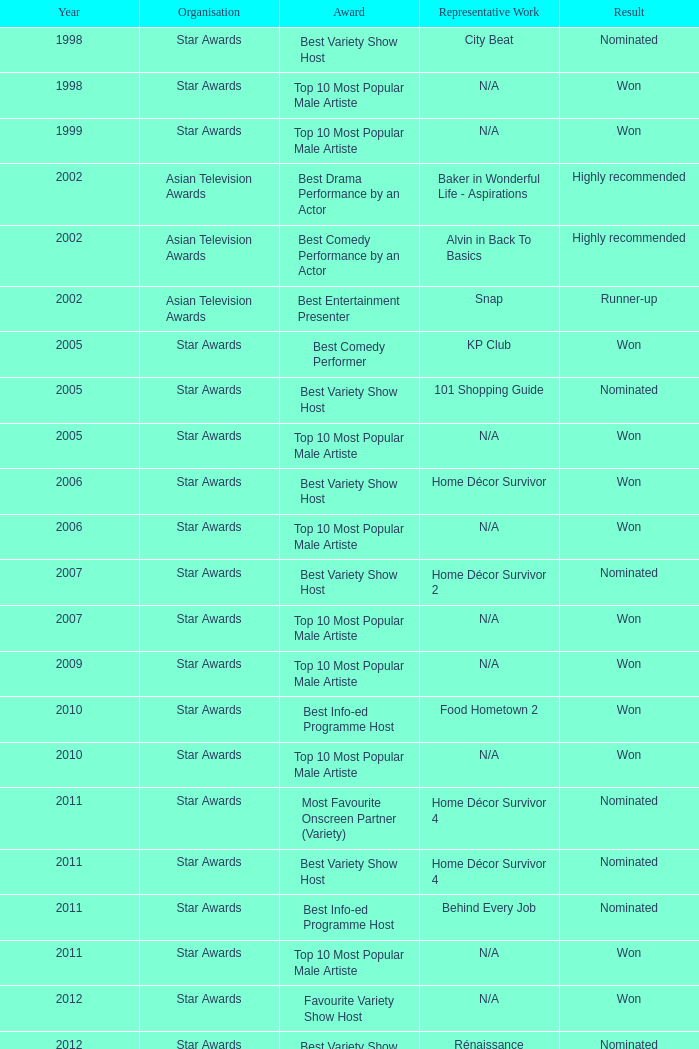Could you help me parse every detail presented in this table? {'header': ['Year', 'Organisation', 'Award', 'Representative Work', 'Result'], 'rows': [['1998', 'Star Awards', 'Best Variety Show Host', 'City Beat', 'Nominated'], ['1998', 'Star Awards', 'Top 10 Most Popular Male Artiste', 'N/A', 'Won'], ['1999', 'Star Awards', 'Top 10 Most Popular Male Artiste', 'N/A', 'Won'], ['2002', 'Asian Television Awards', 'Best Drama Performance by an Actor', 'Baker in Wonderful Life - Aspirations', 'Highly recommended'], ['2002', 'Asian Television Awards', 'Best Comedy Performance by an Actor', 'Alvin in Back To Basics', 'Highly recommended'], ['2002', 'Asian Television Awards', 'Best Entertainment Presenter', 'Snap', 'Runner-up'], ['2005', 'Star Awards', 'Best Comedy Performer', 'KP Club', 'Won'], ['2005', 'Star Awards', 'Best Variety Show Host', '101 Shopping Guide', 'Nominated'], ['2005', 'Star Awards', 'Top 10 Most Popular Male Artiste', 'N/A', 'Won'], ['2006', 'Star Awards', 'Best Variety Show Host', 'Home Décor Survivor', 'Won'], ['2006', 'Star Awards', 'Top 10 Most Popular Male Artiste', 'N/A', 'Won'], ['2007', 'Star Awards', 'Best Variety Show Host', 'Home Décor Survivor 2', 'Nominated'], ['2007', 'Star Awards', 'Top 10 Most Popular Male Artiste', 'N/A', 'Won'], ['2009', 'Star Awards', 'Top 10 Most Popular Male Artiste', 'N/A', 'Won'], ['2010', 'Star Awards', 'Best Info-ed Programme Host', 'Food Hometown 2', 'Won'], ['2010', 'Star Awards', 'Top 10 Most Popular Male Artiste', 'N/A', 'Won'], ['2011', 'Star Awards', 'Most Favourite Onscreen Partner (Variety)', 'Home Décor Survivor 4', 'Nominated'], ['2011', 'Star Awards', 'Best Variety Show Host', 'Home Décor Survivor 4', 'Nominated'], ['2011', 'Star Awards', 'Best Info-ed Programme Host', 'Behind Every Job', 'Nominated'], ['2011', 'Star Awards', 'Top 10 Most Popular Male Artiste', 'N/A', 'Won'], ['2012', 'Star Awards', 'Favourite Variety Show Host', 'N/A', 'Won'], ['2012', 'Star Awards', 'Best Variety Show Host', 'Rénaissance', 'Nominated'], ['2012', 'Star Awards', 'Best Info-ed Programme Host', 'Behind Every Job 2', 'Nominated'], ['2012', 'Star Awards', 'Top 10 Most Popular Male Artiste', 'N/A', 'Won'], ['2013', 'Star Awards', 'Favourite Variety Show Host', 'S.N.A.P. 熠熠星光总动员', 'Won'], ['2013', 'Star Awards', 'Top 10 Most Popular Male Artiste', 'N/A', 'Won'], ['2013', 'Star Awards', 'Best Info-Ed Programme Host', 'Makan Unlimited', 'Nominated'], ['2013', 'Star Awards', 'Best Variety Show Host', 'Jobs Around The World', 'Nominated']]} What is the name of the Representative Work in a year later than 2005 with a Result of nominated, and an Award of best variety show host? Home Décor Survivor 2, Home Décor Survivor 4, Rénaissance, Jobs Around The World. 